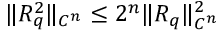Convert formula to latex. <formula><loc_0><loc_0><loc_500><loc_500>\| R _ { q } ^ { 2 } \| _ { C ^ { n } } \leq 2 ^ { n } \| R _ { q } \| _ { C ^ { n } } ^ { 2 }</formula> 